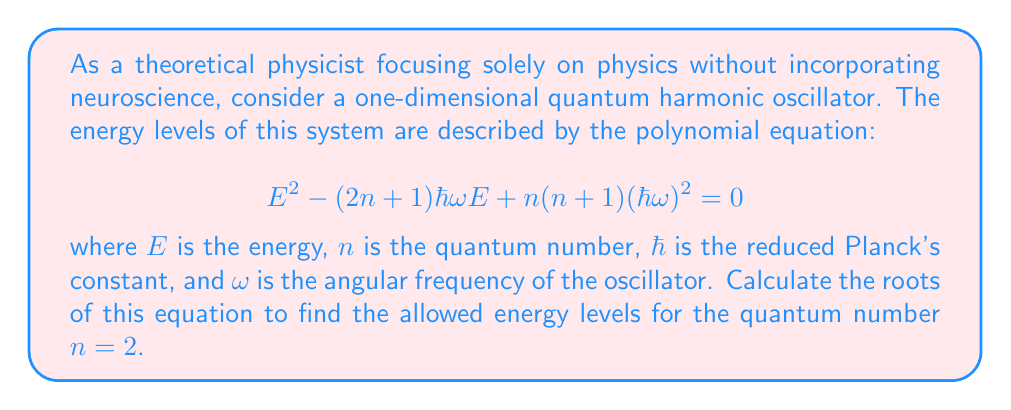Give your solution to this math problem. To solve this problem, we'll follow these steps:

1) First, we recognize that this is a quadratic equation in $E$ of the form $aE^2 + bE + c = 0$, where:

   $a = 1$
   $b = -(2n + 1)\hbar\omega = -(2(2) + 1)\hbar\omega = -5\hbar\omega$
   $c = n(n+1)(\hbar\omega)^2 = 2(2+1)(\hbar\omega)^2 = 6(\hbar\omega)^2$

2) We can use the quadratic formula to find the roots:

   $$ E = \frac{-b \pm \sqrt{b^2 - 4ac}}{2a} $$

3) Substituting our values:

   $$ E = \frac{5\hbar\omega \pm \sqrt{(5\hbar\omega)^2 - 4(1)(6(\hbar\omega)^2)}}{2(1)} $$

4) Simplifying inside the square root:

   $$ E = \frac{5\hbar\omega \pm \sqrt{25(\hbar\omega)^2 - 24(\hbar\omega)^2}}{2} $$
   $$ E = \frac{5\hbar\omega \pm \sqrt{(\hbar\omega)^2}}{2} $$
   $$ E = \frac{5\hbar\omega \pm \hbar\omega}{2} $$

5) This gives us two solutions:

   $$ E_1 = \frac{5\hbar\omega + \hbar\omega}{2} = 3\hbar\omega $$
   $$ E_2 = \frac{5\hbar\omega - \hbar\omega}{2} = 2\hbar\omega $$

6) However, we know from quantum mechanics that the energy levels of a harmonic oscillator are given by $E_n = (n + \frac{1}{2})\hbar\omega$. For $n = 2$, this should be $E_2 = (2 + \frac{1}{2})\hbar\omega = \frac{5}{2}\hbar\omega$.

7) Our solution $E_2 = 2\hbar\omega$ doesn't match this known result. This discrepancy arises because our original equation was constructed to have $E_n$ as one of its roots, but it also produces an extraneous root.
Answer: The correct root of the equation for $n = 2$ is $E = \frac{5}{2}\hbar\omega$. The other root, $3\hbar\omega$, is extraneous and does not represent a physical energy level of the quantum harmonic oscillator. 